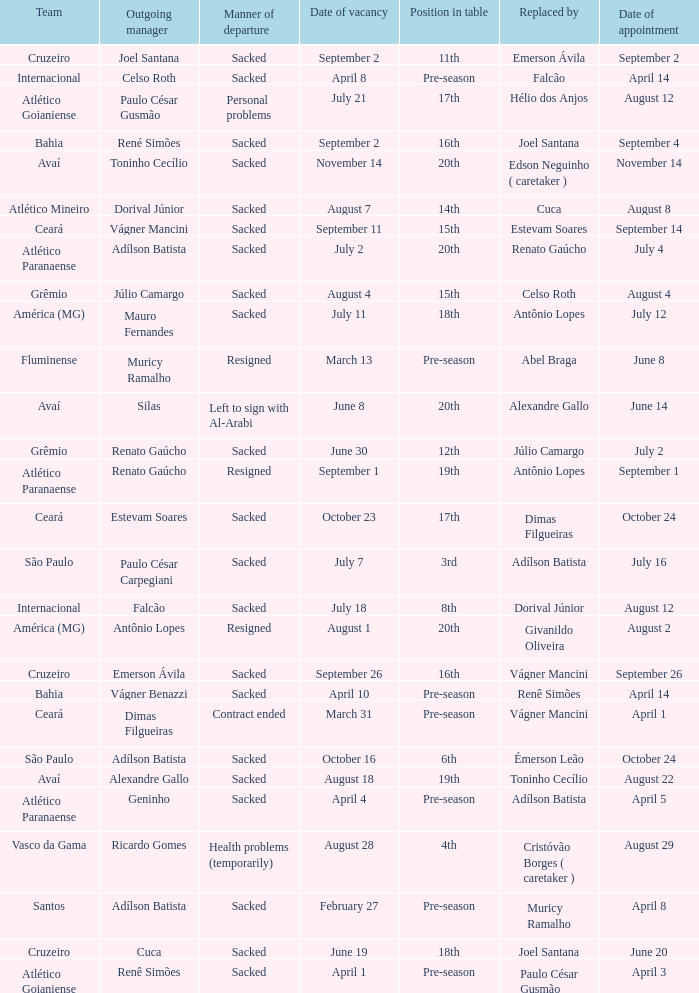Who was the new Santos manager? Muricy Ramalho. 